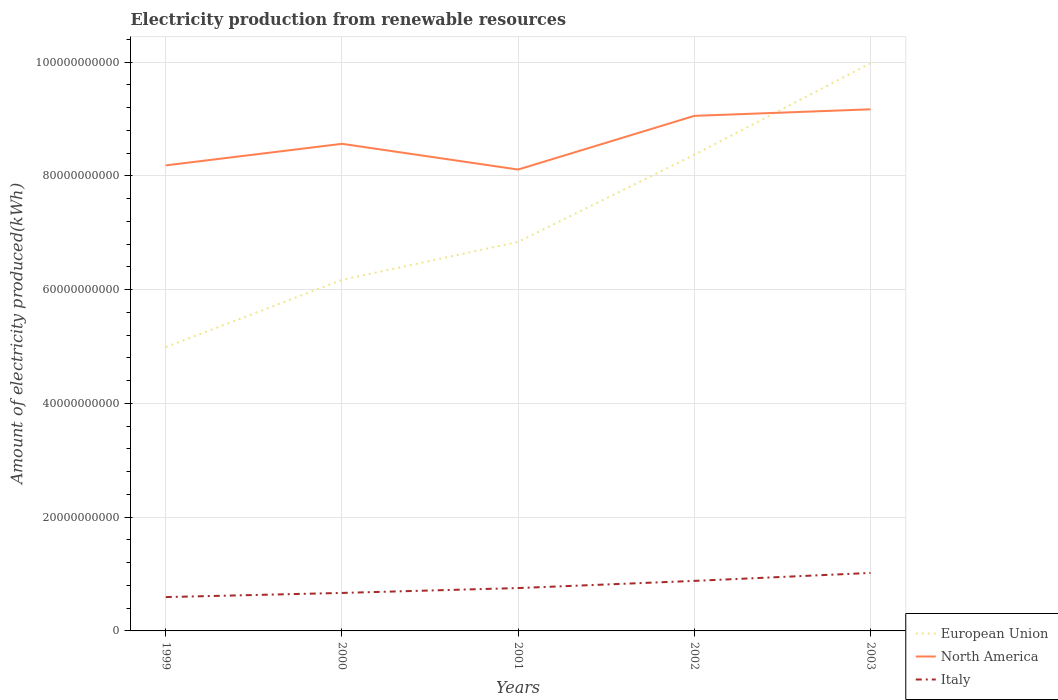Is the number of lines equal to the number of legend labels?
Your response must be concise. Yes. Across all years, what is the maximum amount of electricity produced in North America?
Offer a very short reply. 8.11e+1. In which year was the amount of electricity produced in Italy maximum?
Your answer should be compact. 1999. What is the total amount of electricity produced in European Union in the graph?
Provide a short and direct response. -3.38e+1. What is the difference between the highest and the second highest amount of electricity produced in Italy?
Your answer should be compact. 4.25e+09. How many lines are there?
Keep it short and to the point. 3. How many years are there in the graph?
Your response must be concise. 5. What is the difference between two consecutive major ticks on the Y-axis?
Provide a short and direct response. 2.00e+1. Does the graph contain any zero values?
Offer a terse response. No. Does the graph contain grids?
Offer a terse response. Yes. How are the legend labels stacked?
Give a very brief answer. Vertical. What is the title of the graph?
Give a very brief answer. Electricity production from renewable resources. Does "Benin" appear as one of the legend labels in the graph?
Your answer should be very brief. No. What is the label or title of the Y-axis?
Provide a short and direct response. Amount of electricity produced(kWh). What is the Amount of electricity produced(kWh) of European Union in 1999?
Your answer should be very brief. 4.99e+1. What is the Amount of electricity produced(kWh) in North America in 1999?
Provide a short and direct response. 8.19e+1. What is the Amount of electricity produced(kWh) in Italy in 1999?
Provide a short and direct response. 5.95e+09. What is the Amount of electricity produced(kWh) in European Union in 2000?
Your answer should be very brief. 6.17e+1. What is the Amount of electricity produced(kWh) of North America in 2000?
Your answer should be very brief. 8.56e+1. What is the Amount of electricity produced(kWh) in Italy in 2000?
Ensure brevity in your answer.  6.68e+09. What is the Amount of electricity produced(kWh) in European Union in 2001?
Make the answer very short. 6.84e+1. What is the Amount of electricity produced(kWh) in North America in 2001?
Your response must be concise. 8.11e+1. What is the Amount of electricity produced(kWh) of Italy in 2001?
Offer a terse response. 7.54e+09. What is the Amount of electricity produced(kWh) of European Union in 2002?
Provide a short and direct response. 8.37e+1. What is the Amount of electricity produced(kWh) of North America in 2002?
Offer a terse response. 9.06e+1. What is the Amount of electricity produced(kWh) of Italy in 2002?
Offer a very short reply. 8.80e+09. What is the Amount of electricity produced(kWh) in European Union in 2003?
Provide a short and direct response. 9.98e+1. What is the Amount of electricity produced(kWh) in North America in 2003?
Provide a succinct answer. 9.17e+1. What is the Amount of electricity produced(kWh) of Italy in 2003?
Keep it short and to the point. 1.02e+1. Across all years, what is the maximum Amount of electricity produced(kWh) in European Union?
Offer a terse response. 9.98e+1. Across all years, what is the maximum Amount of electricity produced(kWh) in North America?
Offer a very short reply. 9.17e+1. Across all years, what is the maximum Amount of electricity produced(kWh) in Italy?
Offer a terse response. 1.02e+1. Across all years, what is the minimum Amount of electricity produced(kWh) of European Union?
Keep it short and to the point. 4.99e+1. Across all years, what is the minimum Amount of electricity produced(kWh) of North America?
Provide a succinct answer. 8.11e+1. Across all years, what is the minimum Amount of electricity produced(kWh) in Italy?
Your answer should be compact. 5.95e+09. What is the total Amount of electricity produced(kWh) of European Union in the graph?
Keep it short and to the point. 3.64e+11. What is the total Amount of electricity produced(kWh) of North America in the graph?
Offer a very short reply. 4.31e+11. What is the total Amount of electricity produced(kWh) in Italy in the graph?
Your answer should be compact. 3.92e+1. What is the difference between the Amount of electricity produced(kWh) of European Union in 1999 and that in 2000?
Provide a short and direct response. -1.18e+1. What is the difference between the Amount of electricity produced(kWh) of North America in 1999 and that in 2000?
Ensure brevity in your answer.  -3.79e+09. What is the difference between the Amount of electricity produced(kWh) in Italy in 1999 and that in 2000?
Make the answer very short. -7.30e+08. What is the difference between the Amount of electricity produced(kWh) of European Union in 1999 and that in 2001?
Offer a terse response. -1.85e+1. What is the difference between the Amount of electricity produced(kWh) in North America in 1999 and that in 2001?
Offer a very short reply. 7.32e+08. What is the difference between the Amount of electricity produced(kWh) of Italy in 1999 and that in 2001?
Offer a terse response. -1.59e+09. What is the difference between the Amount of electricity produced(kWh) of European Union in 1999 and that in 2002?
Your answer should be very brief. -3.38e+1. What is the difference between the Amount of electricity produced(kWh) in North America in 1999 and that in 2002?
Provide a short and direct response. -8.71e+09. What is the difference between the Amount of electricity produced(kWh) in Italy in 1999 and that in 2002?
Offer a very short reply. -2.85e+09. What is the difference between the Amount of electricity produced(kWh) of European Union in 1999 and that in 2003?
Your answer should be very brief. -4.99e+1. What is the difference between the Amount of electricity produced(kWh) of North America in 1999 and that in 2003?
Give a very brief answer. -9.86e+09. What is the difference between the Amount of electricity produced(kWh) in Italy in 1999 and that in 2003?
Your response must be concise. -4.25e+09. What is the difference between the Amount of electricity produced(kWh) of European Union in 2000 and that in 2001?
Your response must be concise. -6.68e+09. What is the difference between the Amount of electricity produced(kWh) of North America in 2000 and that in 2001?
Provide a succinct answer. 4.52e+09. What is the difference between the Amount of electricity produced(kWh) of Italy in 2000 and that in 2001?
Give a very brief answer. -8.57e+08. What is the difference between the Amount of electricity produced(kWh) in European Union in 2000 and that in 2002?
Make the answer very short. -2.20e+1. What is the difference between the Amount of electricity produced(kWh) of North America in 2000 and that in 2002?
Your response must be concise. -4.92e+09. What is the difference between the Amount of electricity produced(kWh) in Italy in 2000 and that in 2002?
Provide a succinct answer. -2.12e+09. What is the difference between the Amount of electricity produced(kWh) in European Union in 2000 and that in 2003?
Your response must be concise. -3.81e+1. What is the difference between the Amount of electricity produced(kWh) of North America in 2000 and that in 2003?
Your answer should be compact. -6.07e+09. What is the difference between the Amount of electricity produced(kWh) of Italy in 2000 and that in 2003?
Offer a terse response. -3.52e+09. What is the difference between the Amount of electricity produced(kWh) in European Union in 2001 and that in 2002?
Provide a succinct answer. -1.53e+1. What is the difference between the Amount of electricity produced(kWh) in North America in 2001 and that in 2002?
Provide a short and direct response. -9.44e+09. What is the difference between the Amount of electricity produced(kWh) in Italy in 2001 and that in 2002?
Your response must be concise. -1.26e+09. What is the difference between the Amount of electricity produced(kWh) of European Union in 2001 and that in 2003?
Your answer should be very brief. -3.14e+1. What is the difference between the Amount of electricity produced(kWh) in North America in 2001 and that in 2003?
Offer a terse response. -1.06e+1. What is the difference between the Amount of electricity produced(kWh) of Italy in 2001 and that in 2003?
Provide a short and direct response. -2.66e+09. What is the difference between the Amount of electricity produced(kWh) in European Union in 2002 and that in 2003?
Your response must be concise. -1.61e+1. What is the difference between the Amount of electricity produced(kWh) in North America in 2002 and that in 2003?
Give a very brief answer. -1.15e+09. What is the difference between the Amount of electricity produced(kWh) of Italy in 2002 and that in 2003?
Offer a terse response. -1.40e+09. What is the difference between the Amount of electricity produced(kWh) in European Union in 1999 and the Amount of electricity produced(kWh) in North America in 2000?
Keep it short and to the point. -3.57e+1. What is the difference between the Amount of electricity produced(kWh) in European Union in 1999 and the Amount of electricity produced(kWh) in Italy in 2000?
Provide a succinct answer. 4.32e+1. What is the difference between the Amount of electricity produced(kWh) of North America in 1999 and the Amount of electricity produced(kWh) of Italy in 2000?
Your answer should be very brief. 7.52e+1. What is the difference between the Amount of electricity produced(kWh) in European Union in 1999 and the Amount of electricity produced(kWh) in North America in 2001?
Your answer should be compact. -3.12e+1. What is the difference between the Amount of electricity produced(kWh) of European Union in 1999 and the Amount of electricity produced(kWh) of Italy in 2001?
Offer a terse response. 4.24e+1. What is the difference between the Amount of electricity produced(kWh) in North America in 1999 and the Amount of electricity produced(kWh) in Italy in 2001?
Offer a terse response. 7.43e+1. What is the difference between the Amount of electricity produced(kWh) in European Union in 1999 and the Amount of electricity produced(kWh) in North America in 2002?
Keep it short and to the point. -4.07e+1. What is the difference between the Amount of electricity produced(kWh) in European Union in 1999 and the Amount of electricity produced(kWh) in Italy in 2002?
Your response must be concise. 4.11e+1. What is the difference between the Amount of electricity produced(kWh) of North America in 1999 and the Amount of electricity produced(kWh) of Italy in 2002?
Keep it short and to the point. 7.31e+1. What is the difference between the Amount of electricity produced(kWh) of European Union in 1999 and the Amount of electricity produced(kWh) of North America in 2003?
Give a very brief answer. -4.18e+1. What is the difference between the Amount of electricity produced(kWh) of European Union in 1999 and the Amount of electricity produced(kWh) of Italy in 2003?
Provide a short and direct response. 3.97e+1. What is the difference between the Amount of electricity produced(kWh) in North America in 1999 and the Amount of electricity produced(kWh) in Italy in 2003?
Your answer should be very brief. 7.17e+1. What is the difference between the Amount of electricity produced(kWh) of European Union in 2000 and the Amount of electricity produced(kWh) of North America in 2001?
Provide a short and direct response. -1.94e+1. What is the difference between the Amount of electricity produced(kWh) in European Union in 2000 and the Amount of electricity produced(kWh) in Italy in 2001?
Your answer should be compact. 5.42e+1. What is the difference between the Amount of electricity produced(kWh) in North America in 2000 and the Amount of electricity produced(kWh) in Italy in 2001?
Make the answer very short. 7.81e+1. What is the difference between the Amount of electricity produced(kWh) of European Union in 2000 and the Amount of electricity produced(kWh) of North America in 2002?
Make the answer very short. -2.88e+1. What is the difference between the Amount of electricity produced(kWh) in European Union in 2000 and the Amount of electricity produced(kWh) in Italy in 2002?
Give a very brief answer. 5.29e+1. What is the difference between the Amount of electricity produced(kWh) of North America in 2000 and the Amount of electricity produced(kWh) of Italy in 2002?
Your response must be concise. 7.68e+1. What is the difference between the Amount of electricity produced(kWh) in European Union in 2000 and the Amount of electricity produced(kWh) in North America in 2003?
Offer a terse response. -3.00e+1. What is the difference between the Amount of electricity produced(kWh) in European Union in 2000 and the Amount of electricity produced(kWh) in Italy in 2003?
Your answer should be very brief. 5.15e+1. What is the difference between the Amount of electricity produced(kWh) of North America in 2000 and the Amount of electricity produced(kWh) of Italy in 2003?
Offer a very short reply. 7.54e+1. What is the difference between the Amount of electricity produced(kWh) in European Union in 2001 and the Amount of electricity produced(kWh) in North America in 2002?
Ensure brevity in your answer.  -2.22e+1. What is the difference between the Amount of electricity produced(kWh) in European Union in 2001 and the Amount of electricity produced(kWh) in Italy in 2002?
Offer a terse response. 5.96e+1. What is the difference between the Amount of electricity produced(kWh) in North America in 2001 and the Amount of electricity produced(kWh) in Italy in 2002?
Your response must be concise. 7.23e+1. What is the difference between the Amount of electricity produced(kWh) in European Union in 2001 and the Amount of electricity produced(kWh) in North America in 2003?
Make the answer very short. -2.33e+1. What is the difference between the Amount of electricity produced(kWh) of European Union in 2001 and the Amount of electricity produced(kWh) of Italy in 2003?
Your answer should be very brief. 5.82e+1. What is the difference between the Amount of electricity produced(kWh) in North America in 2001 and the Amount of electricity produced(kWh) in Italy in 2003?
Keep it short and to the point. 7.09e+1. What is the difference between the Amount of electricity produced(kWh) in European Union in 2002 and the Amount of electricity produced(kWh) in North America in 2003?
Provide a succinct answer. -7.99e+09. What is the difference between the Amount of electricity produced(kWh) of European Union in 2002 and the Amount of electricity produced(kWh) of Italy in 2003?
Make the answer very short. 7.35e+1. What is the difference between the Amount of electricity produced(kWh) in North America in 2002 and the Amount of electricity produced(kWh) in Italy in 2003?
Give a very brief answer. 8.04e+1. What is the average Amount of electricity produced(kWh) in European Union per year?
Give a very brief answer. 7.27e+1. What is the average Amount of electricity produced(kWh) of North America per year?
Your response must be concise. 8.62e+1. What is the average Amount of electricity produced(kWh) in Italy per year?
Provide a succinct answer. 7.83e+09. In the year 1999, what is the difference between the Amount of electricity produced(kWh) of European Union and Amount of electricity produced(kWh) of North America?
Offer a very short reply. -3.19e+1. In the year 1999, what is the difference between the Amount of electricity produced(kWh) in European Union and Amount of electricity produced(kWh) in Italy?
Your answer should be very brief. 4.40e+1. In the year 1999, what is the difference between the Amount of electricity produced(kWh) in North America and Amount of electricity produced(kWh) in Italy?
Ensure brevity in your answer.  7.59e+1. In the year 2000, what is the difference between the Amount of electricity produced(kWh) in European Union and Amount of electricity produced(kWh) in North America?
Keep it short and to the point. -2.39e+1. In the year 2000, what is the difference between the Amount of electricity produced(kWh) of European Union and Amount of electricity produced(kWh) of Italy?
Keep it short and to the point. 5.50e+1. In the year 2000, what is the difference between the Amount of electricity produced(kWh) of North America and Amount of electricity produced(kWh) of Italy?
Keep it short and to the point. 7.90e+1. In the year 2001, what is the difference between the Amount of electricity produced(kWh) of European Union and Amount of electricity produced(kWh) of North America?
Your answer should be compact. -1.27e+1. In the year 2001, what is the difference between the Amount of electricity produced(kWh) in European Union and Amount of electricity produced(kWh) in Italy?
Offer a terse response. 6.09e+1. In the year 2001, what is the difference between the Amount of electricity produced(kWh) in North America and Amount of electricity produced(kWh) in Italy?
Provide a short and direct response. 7.36e+1. In the year 2002, what is the difference between the Amount of electricity produced(kWh) of European Union and Amount of electricity produced(kWh) of North America?
Give a very brief answer. -6.84e+09. In the year 2002, what is the difference between the Amount of electricity produced(kWh) in European Union and Amount of electricity produced(kWh) in Italy?
Your answer should be very brief. 7.49e+1. In the year 2002, what is the difference between the Amount of electricity produced(kWh) of North America and Amount of electricity produced(kWh) of Italy?
Offer a very short reply. 8.18e+1. In the year 2003, what is the difference between the Amount of electricity produced(kWh) in European Union and Amount of electricity produced(kWh) in North America?
Offer a terse response. 8.10e+09. In the year 2003, what is the difference between the Amount of electricity produced(kWh) of European Union and Amount of electricity produced(kWh) of Italy?
Ensure brevity in your answer.  8.96e+1. In the year 2003, what is the difference between the Amount of electricity produced(kWh) of North America and Amount of electricity produced(kWh) of Italy?
Give a very brief answer. 8.15e+1. What is the ratio of the Amount of electricity produced(kWh) of European Union in 1999 to that in 2000?
Give a very brief answer. 0.81. What is the ratio of the Amount of electricity produced(kWh) of North America in 1999 to that in 2000?
Offer a very short reply. 0.96. What is the ratio of the Amount of electricity produced(kWh) of Italy in 1999 to that in 2000?
Offer a very short reply. 0.89. What is the ratio of the Amount of electricity produced(kWh) of European Union in 1999 to that in 2001?
Offer a very short reply. 0.73. What is the ratio of the Amount of electricity produced(kWh) in North America in 1999 to that in 2001?
Give a very brief answer. 1.01. What is the ratio of the Amount of electricity produced(kWh) in Italy in 1999 to that in 2001?
Provide a short and direct response. 0.79. What is the ratio of the Amount of electricity produced(kWh) in European Union in 1999 to that in 2002?
Provide a short and direct response. 0.6. What is the ratio of the Amount of electricity produced(kWh) in North America in 1999 to that in 2002?
Your answer should be compact. 0.9. What is the ratio of the Amount of electricity produced(kWh) of Italy in 1999 to that in 2002?
Your response must be concise. 0.68. What is the ratio of the Amount of electricity produced(kWh) in North America in 1999 to that in 2003?
Keep it short and to the point. 0.89. What is the ratio of the Amount of electricity produced(kWh) in Italy in 1999 to that in 2003?
Your answer should be compact. 0.58. What is the ratio of the Amount of electricity produced(kWh) of European Union in 2000 to that in 2001?
Provide a short and direct response. 0.9. What is the ratio of the Amount of electricity produced(kWh) in North America in 2000 to that in 2001?
Your answer should be very brief. 1.06. What is the ratio of the Amount of electricity produced(kWh) in Italy in 2000 to that in 2001?
Offer a terse response. 0.89. What is the ratio of the Amount of electricity produced(kWh) in European Union in 2000 to that in 2002?
Offer a very short reply. 0.74. What is the ratio of the Amount of electricity produced(kWh) in North America in 2000 to that in 2002?
Give a very brief answer. 0.95. What is the ratio of the Amount of electricity produced(kWh) of Italy in 2000 to that in 2002?
Offer a very short reply. 0.76. What is the ratio of the Amount of electricity produced(kWh) in European Union in 2000 to that in 2003?
Keep it short and to the point. 0.62. What is the ratio of the Amount of electricity produced(kWh) of North America in 2000 to that in 2003?
Make the answer very short. 0.93. What is the ratio of the Amount of electricity produced(kWh) of Italy in 2000 to that in 2003?
Offer a very short reply. 0.66. What is the ratio of the Amount of electricity produced(kWh) in European Union in 2001 to that in 2002?
Your response must be concise. 0.82. What is the ratio of the Amount of electricity produced(kWh) of North America in 2001 to that in 2002?
Your response must be concise. 0.9. What is the ratio of the Amount of electricity produced(kWh) in Italy in 2001 to that in 2002?
Your answer should be very brief. 0.86. What is the ratio of the Amount of electricity produced(kWh) in European Union in 2001 to that in 2003?
Offer a very short reply. 0.69. What is the ratio of the Amount of electricity produced(kWh) of North America in 2001 to that in 2003?
Your answer should be very brief. 0.88. What is the ratio of the Amount of electricity produced(kWh) in Italy in 2001 to that in 2003?
Ensure brevity in your answer.  0.74. What is the ratio of the Amount of electricity produced(kWh) in European Union in 2002 to that in 2003?
Your response must be concise. 0.84. What is the ratio of the Amount of electricity produced(kWh) of North America in 2002 to that in 2003?
Your answer should be compact. 0.99. What is the ratio of the Amount of electricity produced(kWh) of Italy in 2002 to that in 2003?
Offer a very short reply. 0.86. What is the difference between the highest and the second highest Amount of electricity produced(kWh) of European Union?
Your answer should be compact. 1.61e+1. What is the difference between the highest and the second highest Amount of electricity produced(kWh) of North America?
Offer a very short reply. 1.15e+09. What is the difference between the highest and the second highest Amount of electricity produced(kWh) in Italy?
Your response must be concise. 1.40e+09. What is the difference between the highest and the lowest Amount of electricity produced(kWh) of European Union?
Provide a short and direct response. 4.99e+1. What is the difference between the highest and the lowest Amount of electricity produced(kWh) in North America?
Keep it short and to the point. 1.06e+1. What is the difference between the highest and the lowest Amount of electricity produced(kWh) of Italy?
Offer a terse response. 4.25e+09. 